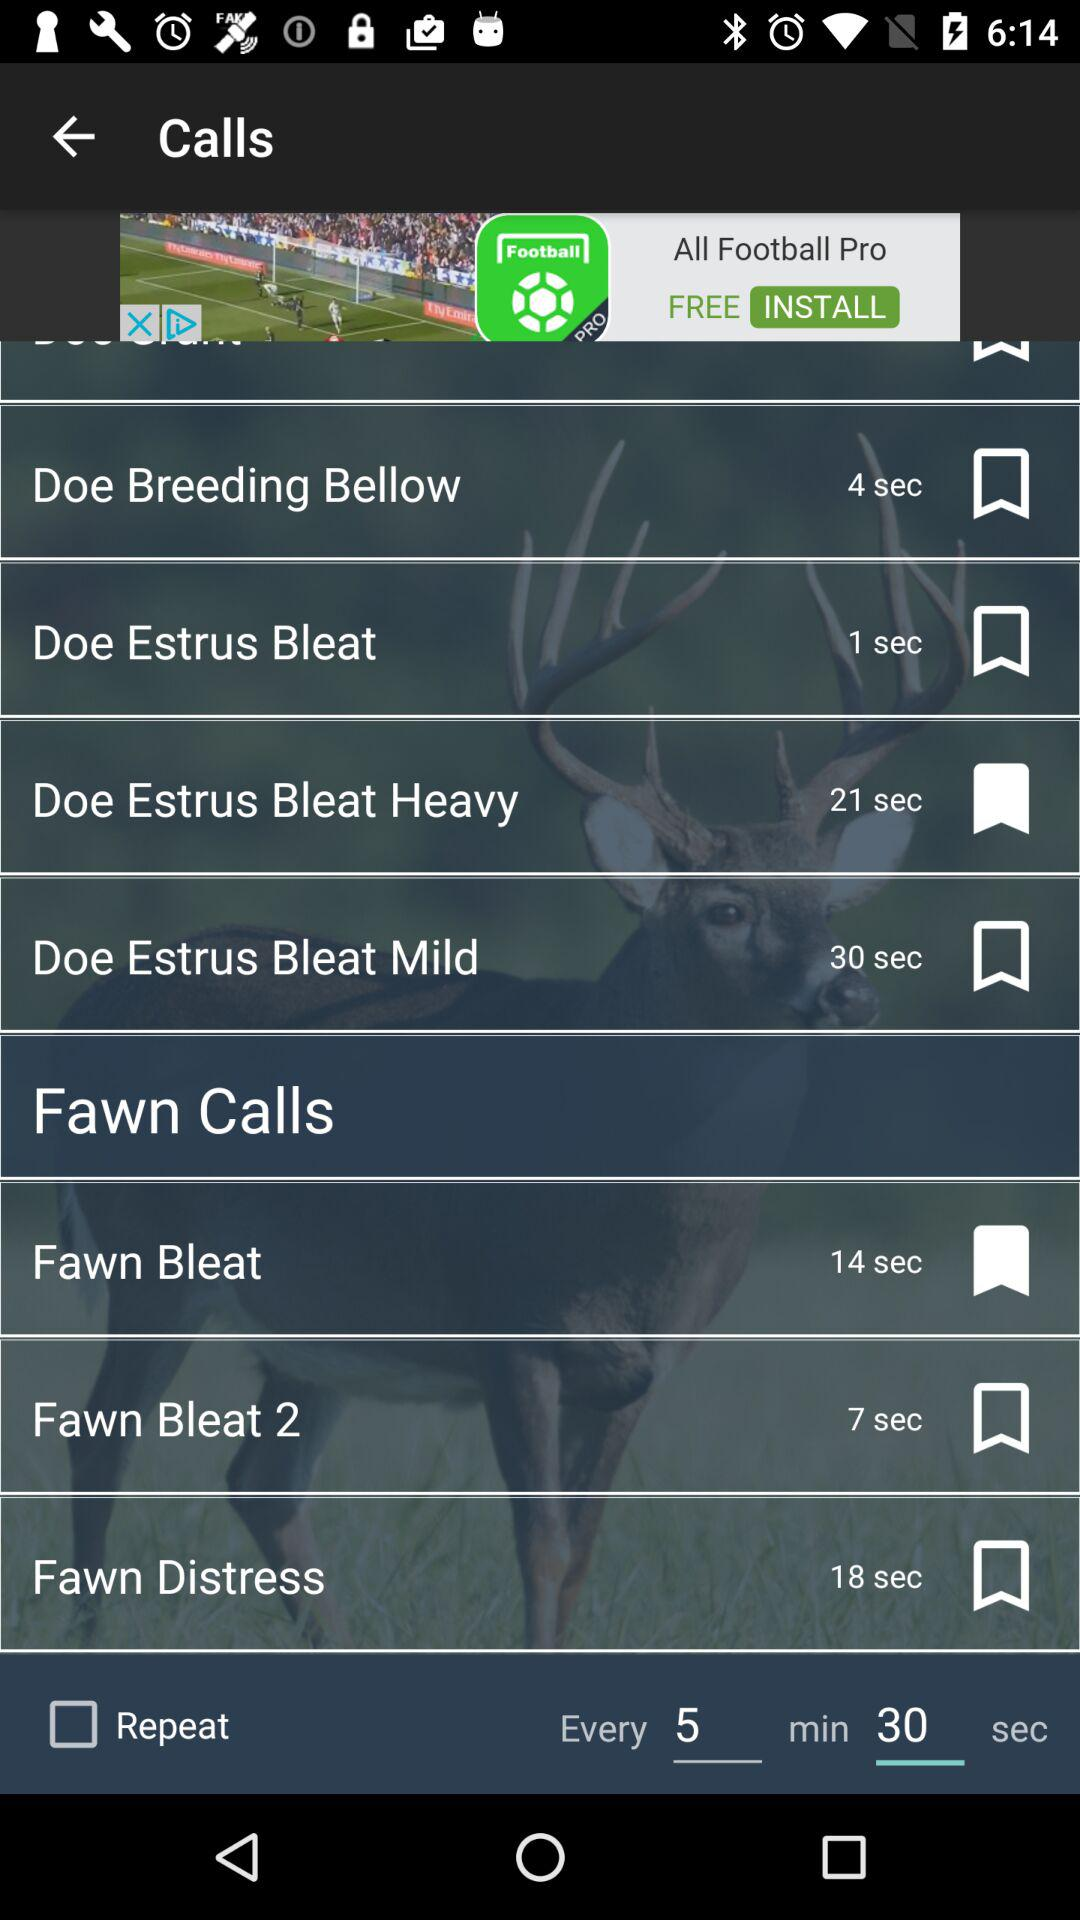How many seconds are in the longest call?
Answer the question using a single word or phrase. 30 